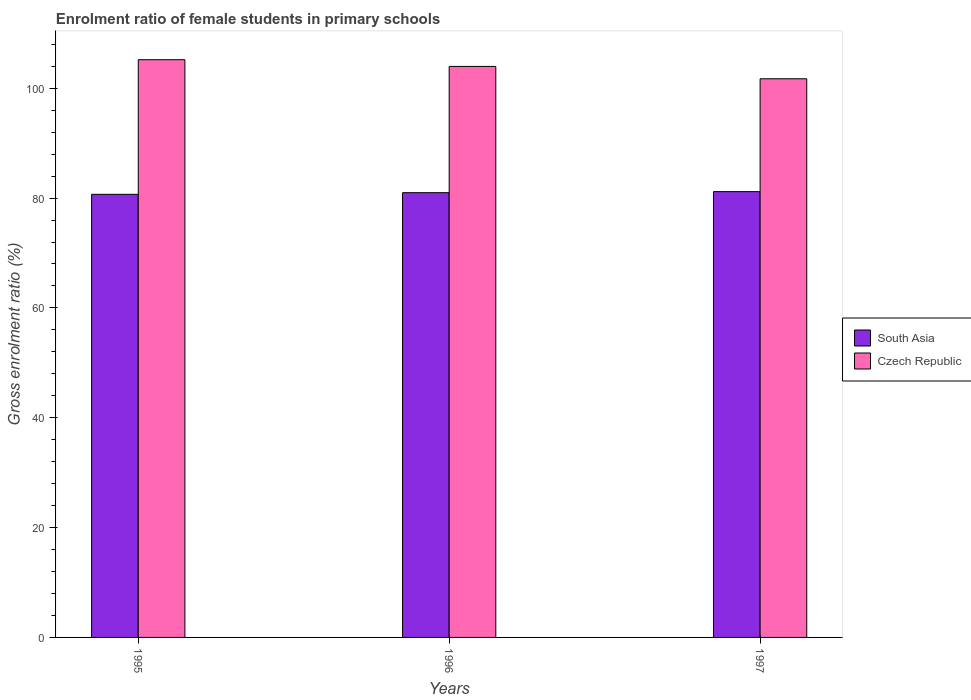How many different coloured bars are there?
Offer a very short reply. 2. Are the number of bars per tick equal to the number of legend labels?
Make the answer very short. Yes. Are the number of bars on each tick of the X-axis equal?
Your answer should be compact. Yes. How many bars are there on the 2nd tick from the left?
Provide a short and direct response. 2. How many bars are there on the 2nd tick from the right?
Ensure brevity in your answer.  2. What is the label of the 3rd group of bars from the left?
Offer a terse response. 1997. What is the enrolment ratio of female students in primary schools in Czech Republic in 1995?
Give a very brief answer. 105.2. Across all years, what is the maximum enrolment ratio of female students in primary schools in Czech Republic?
Your answer should be compact. 105.2. Across all years, what is the minimum enrolment ratio of female students in primary schools in South Asia?
Your answer should be compact. 80.69. What is the total enrolment ratio of female students in primary schools in Czech Republic in the graph?
Provide a short and direct response. 310.9. What is the difference between the enrolment ratio of female students in primary schools in South Asia in 1995 and that in 1997?
Ensure brevity in your answer.  -0.49. What is the difference between the enrolment ratio of female students in primary schools in South Asia in 1997 and the enrolment ratio of female students in primary schools in Czech Republic in 1996?
Give a very brief answer. -22.8. What is the average enrolment ratio of female students in primary schools in South Asia per year?
Give a very brief answer. 80.95. In the year 1996, what is the difference between the enrolment ratio of female students in primary schools in Czech Republic and enrolment ratio of female students in primary schools in South Asia?
Your answer should be very brief. 22.99. In how many years, is the enrolment ratio of female students in primary schools in Czech Republic greater than 8 %?
Ensure brevity in your answer.  3. What is the ratio of the enrolment ratio of female students in primary schools in South Asia in 1996 to that in 1997?
Make the answer very short. 1. Is the enrolment ratio of female students in primary schools in South Asia in 1995 less than that in 1996?
Offer a terse response. Yes. What is the difference between the highest and the second highest enrolment ratio of female students in primary schools in Czech Republic?
Offer a terse response. 1.22. What is the difference between the highest and the lowest enrolment ratio of female students in primary schools in South Asia?
Offer a very short reply. 0.49. Is the sum of the enrolment ratio of female students in primary schools in Czech Republic in 1996 and 1997 greater than the maximum enrolment ratio of female students in primary schools in South Asia across all years?
Ensure brevity in your answer.  Yes. What does the 2nd bar from the left in 1996 represents?
Provide a succinct answer. Czech Republic. What does the 2nd bar from the right in 1997 represents?
Provide a succinct answer. South Asia. How many bars are there?
Provide a succinct answer. 6. What is the difference between two consecutive major ticks on the Y-axis?
Offer a terse response. 20. Does the graph contain grids?
Your response must be concise. No. Where does the legend appear in the graph?
Make the answer very short. Center right. How are the legend labels stacked?
Provide a short and direct response. Vertical. What is the title of the graph?
Make the answer very short. Enrolment ratio of female students in primary schools. What is the label or title of the X-axis?
Keep it short and to the point. Years. What is the Gross enrolment ratio (%) in South Asia in 1995?
Ensure brevity in your answer.  80.69. What is the Gross enrolment ratio (%) of Czech Republic in 1995?
Keep it short and to the point. 105.2. What is the Gross enrolment ratio (%) of South Asia in 1996?
Provide a succinct answer. 80.99. What is the Gross enrolment ratio (%) of Czech Republic in 1996?
Your answer should be compact. 103.98. What is the Gross enrolment ratio (%) of South Asia in 1997?
Make the answer very short. 81.18. What is the Gross enrolment ratio (%) in Czech Republic in 1997?
Provide a succinct answer. 101.73. Across all years, what is the maximum Gross enrolment ratio (%) in South Asia?
Offer a very short reply. 81.18. Across all years, what is the maximum Gross enrolment ratio (%) of Czech Republic?
Ensure brevity in your answer.  105.2. Across all years, what is the minimum Gross enrolment ratio (%) in South Asia?
Provide a succinct answer. 80.69. Across all years, what is the minimum Gross enrolment ratio (%) in Czech Republic?
Offer a very short reply. 101.73. What is the total Gross enrolment ratio (%) of South Asia in the graph?
Your response must be concise. 242.85. What is the total Gross enrolment ratio (%) in Czech Republic in the graph?
Give a very brief answer. 310.9. What is the difference between the Gross enrolment ratio (%) in South Asia in 1995 and that in 1996?
Your response must be concise. -0.3. What is the difference between the Gross enrolment ratio (%) of Czech Republic in 1995 and that in 1996?
Keep it short and to the point. 1.22. What is the difference between the Gross enrolment ratio (%) of South Asia in 1995 and that in 1997?
Your response must be concise. -0.49. What is the difference between the Gross enrolment ratio (%) of Czech Republic in 1995 and that in 1997?
Make the answer very short. 3.47. What is the difference between the Gross enrolment ratio (%) in South Asia in 1996 and that in 1997?
Your answer should be compact. -0.19. What is the difference between the Gross enrolment ratio (%) in Czech Republic in 1996 and that in 1997?
Offer a terse response. 2.25. What is the difference between the Gross enrolment ratio (%) in South Asia in 1995 and the Gross enrolment ratio (%) in Czech Republic in 1996?
Keep it short and to the point. -23.29. What is the difference between the Gross enrolment ratio (%) in South Asia in 1995 and the Gross enrolment ratio (%) in Czech Republic in 1997?
Offer a very short reply. -21.04. What is the difference between the Gross enrolment ratio (%) of South Asia in 1996 and the Gross enrolment ratio (%) of Czech Republic in 1997?
Ensure brevity in your answer.  -20.74. What is the average Gross enrolment ratio (%) of South Asia per year?
Your response must be concise. 80.95. What is the average Gross enrolment ratio (%) in Czech Republic per year?
Provide a succinct answer. 103.63. In the year 1995, what is the difference between the Gross enrolment ratio (%) in South Asia and Gross enrolment ratio (%) in Czech Republic?
Provide a succinct answer. -24.51. In the year 1996, what is the difference between the Gross enrolment ratio (%) of South Asia and Gross enrolment ratio (%) of Czech Republic?
Give a very brief answer. -22.99. In the year 1997, what is the difference between the Gross enrolment ratio (%) in South Asia and Gross enrolment ratio (%) in Czech Republic?
Provide a succinct answer. -20.55. What is the ratio of the Gross enrolment ratio (%) in South Asia in 1995 to that in 1996?
Provide a short and direct response. 1. What is the ratio of the Gross enrolment ratio (%) in Czech Republic in 1995 to that in 1996?
Offer a very short reply. 1.01. What is the ratio of the Gross enrolment ratio (%) in Czech Republic in 1995 to that in 1997?
Offer a very short reply. 1.03. What is the ratio of the Gross enrolment ratio (%) in South Asia in 1996 to that in 1997?
Provide a succinct answer. 1. What is the ratio of the Gross enrolment ratio (%) of Czech Republic in 1996 to that in 1997?
Provide a short and direct response. 1.02. What is the difference between the highest and the second highest Gross enrolment ratio (%) of South Asia?
Your answer should be very brief. 0.19. What is the difference between the highest and the second highest Gross enrolment ratio (%) of Czech Republic?
Make the answer very short. 1.22. What is the difference between the highest and the lowest Gross enrolment ratio (%) of South Asia?
Ensure brevity in your answer.  0.49. What is the difference between the highest and the lowest Gross enrolment ratio (%) of Czech Republic?
Provide a succinct answer. 3.47. 